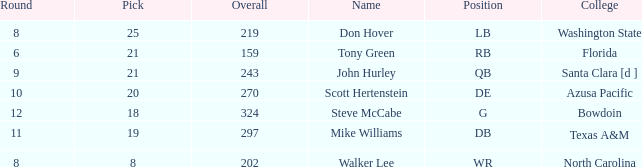What is the average overall that has a pick less than 20, North Carolina as the college, with a round less than 8? None. 